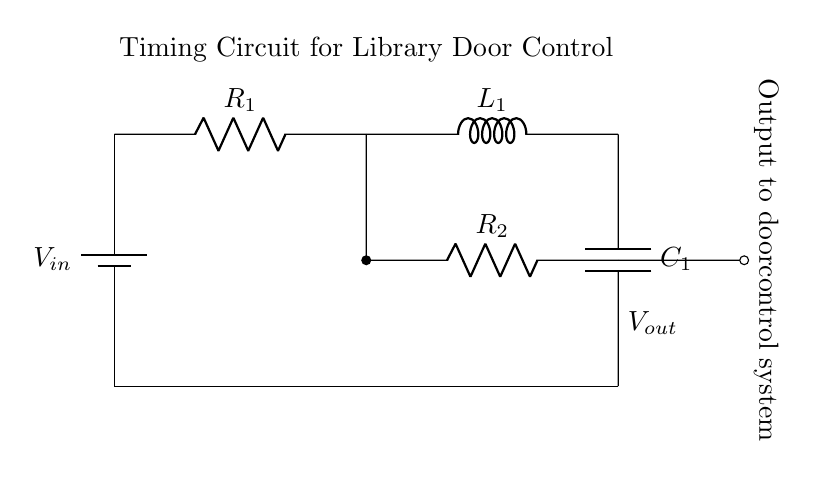What is the input voltage in this circuit? The input voltage is denoted as \( V_{in} \) in the circuit diagram, which is the voltage supplied to the entire timing circuit.
Answer: \( V_{in} \) What components are present in this circuit? The components consist of a battery \( V_{in} \), a resistor \( R_1 \), an inductor \( L_1 \), a capacitor \( C_1 \), and a second resistor \( R_2 \). These are connected in a specific arrangement that forms an RLC circuit.
Answer: Battery, Resistor \( R_1 \), Inductor \( L_1 \), Capacitor \( C_1 \), Resistor \( R_2 \) What is the output of the circuit connected to? The output of the circuit is connected to the door control system, which is indicated in the diagram where the signal is output at the node connected to \( R_2 \).
Answer: Door control system What types of elements are used in the timing circuit? The timing circuit employs a combination of resistors, an inductor, and a capacitor, fundamentally creating an RLC timing circuit that can produce a time delay or control the timing of the signal.
Answer: Resistor, Inductor, Capacitor How do the resistors affect the circuit timing? Resistors \( R_1 \) and \( R_2 \) influence the time constant of the RLC circuit and thus affect the charging and discharging times of the capacitor, which directly impacts the delay before the door opens or closes.
Answer: They affect timing What is the role of the inductor in this circuit? The inductor \( L_1 \) contributes to the energy storage in the magnetic field and can affect the timing behavior and transient response of the circuit, typically inducing a time delay in the response to changes in voltage.
Answer: Energy storage How could you alter the timing for the door opening? To alter the timing for the door opening, you could change values of either resistor \( R_1 \), \( R_2 \), or capacitor \( C_1 \). These components dictate the exponential charge and discharge cycles, influencing the timing behavior of the circuit.
Answer: Change resistors or capacitor 